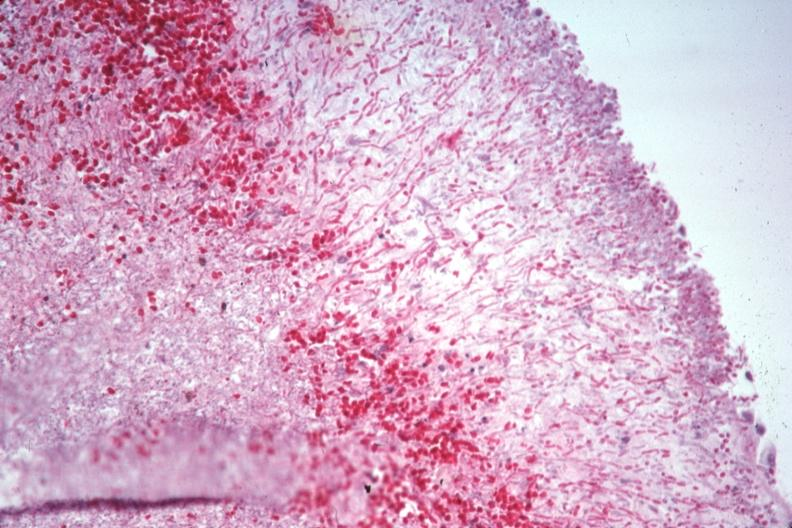s adrenal present?
Answer the question using a single word or phrase. No 